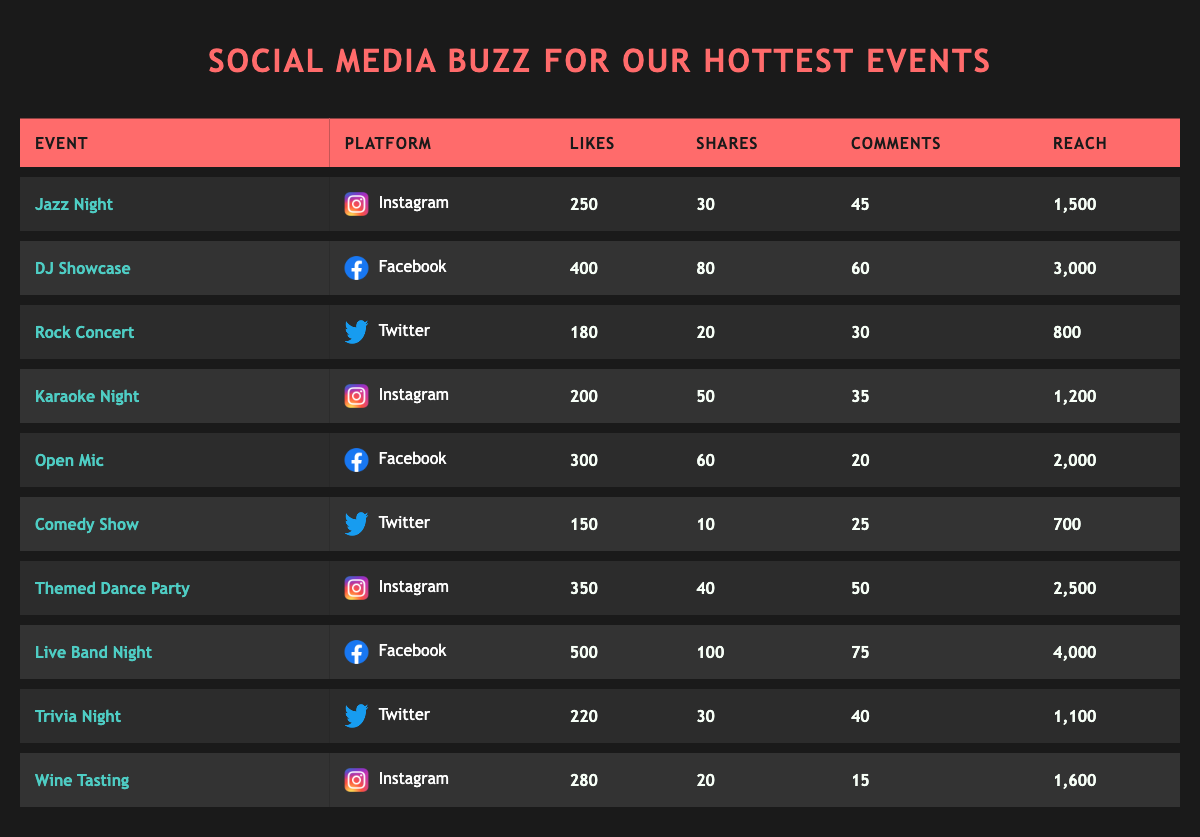What is the highest number of likes for an event? The table lists likes for each event. The maximum value in the likes column is 500 for the event "Live Band Night."
Answer: 500 Which event had the lowest reach? Looking at the reach column, the lowest value is 700 for the "Comedy Show."
Answer: 700 How many total shares were made across all events? To find the total shares, we sum the shares for each event: 30 + 80 + 20 + 50 + 60 + 10 + 40 + 100 + 30 + 20 = 400.
Answer: 400 Is there an event that received more than 300 likes and 70 shares? The "Live Band Night" event fits this criteria with 500 likes and 100 shares, confirming that it exists.
Answer: Yes What is the average number of comments across all events? First, sum all comments: 45 + 60 + 30 + 35 + 20 + 25 + 50 + 75 + 40 + 15 = 455. There are 10 events, so 455/10 = 45.5.
Answer: 45.5 Which social media platform has the most events? Counting each event per platform, there are 4 events on Instagram, 3 on Facebook, and 3 on Twitter. Instagram has the highest count.
Answer: Instagram What is the difference in reach between the highest and lowest event? The highest reach is 4000 (Live Band Night) and the lowest is 700 (Comedy Show). The difference is 4000 - 700 = 3300.
Answer: 3300 Did "Jazz Night" receive more likes than "Karaoke Night"? Comparing likes, "Jazz Night" has 250 likes while "Karaoke Night" has 200 likes. Since 250 > 200, the statement is true.
Answer: Yes What is the total reach of events held on Facebook? Summing the reach for Facebook events: 3000 (DJ Showcase) + 2000 (Open Mic) + 4000 (Live Band Night) = 9000.
Answer: 9000 